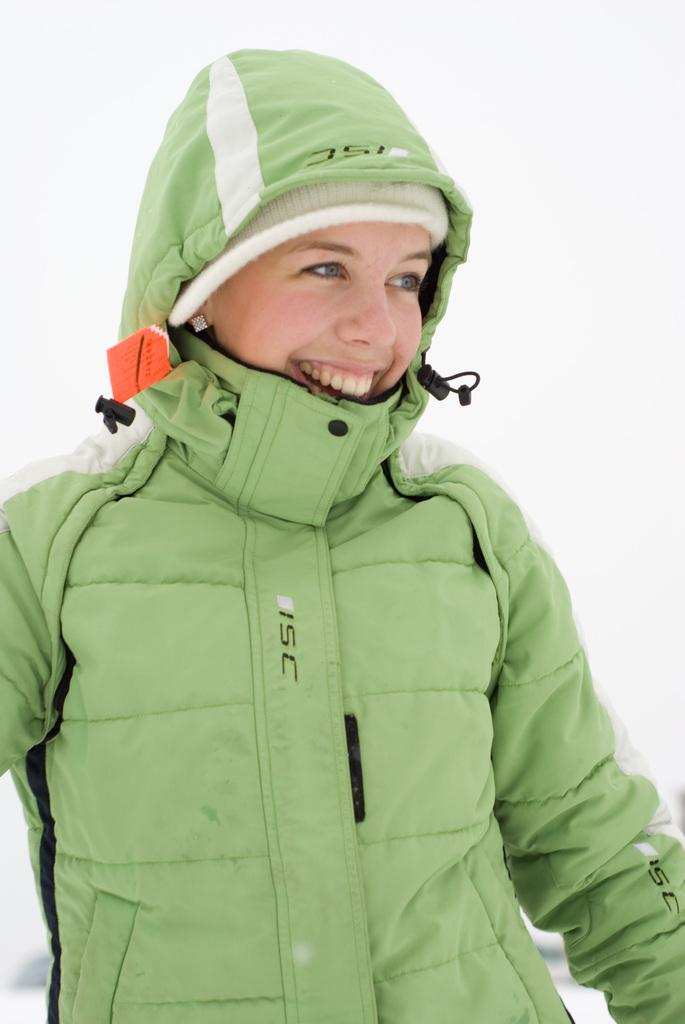What color is the background of the image? The background of the image is white. What is the person in the image wearing? The person is wearing a jacket in the image. What expression does the person have? The person is smiling in the image. How many owls can be seen in the image? There are no owls present in the image. What type of pot is being used by the person in the image? There is no pot visible in the image. 